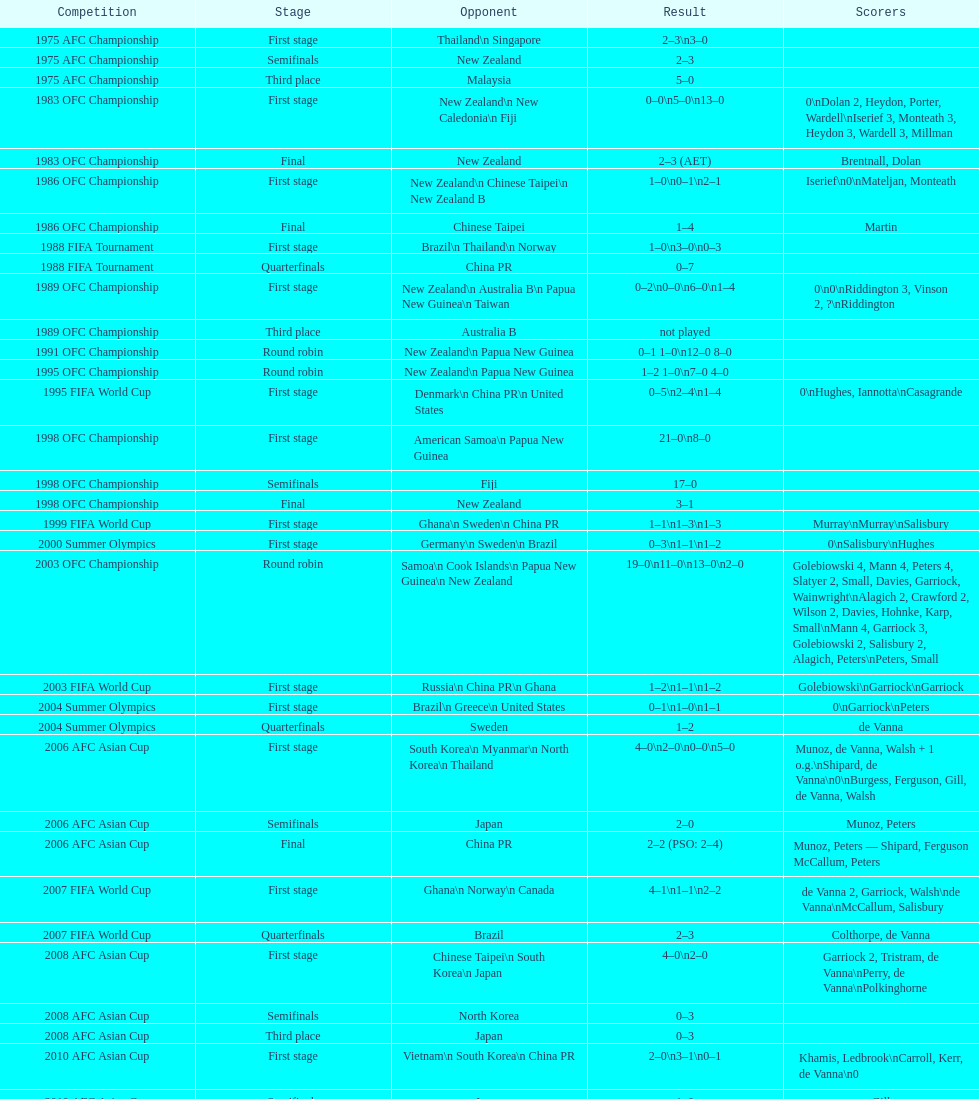Who was the final adversary this team encountered in the 2010 afc asian cup? North Korea. 